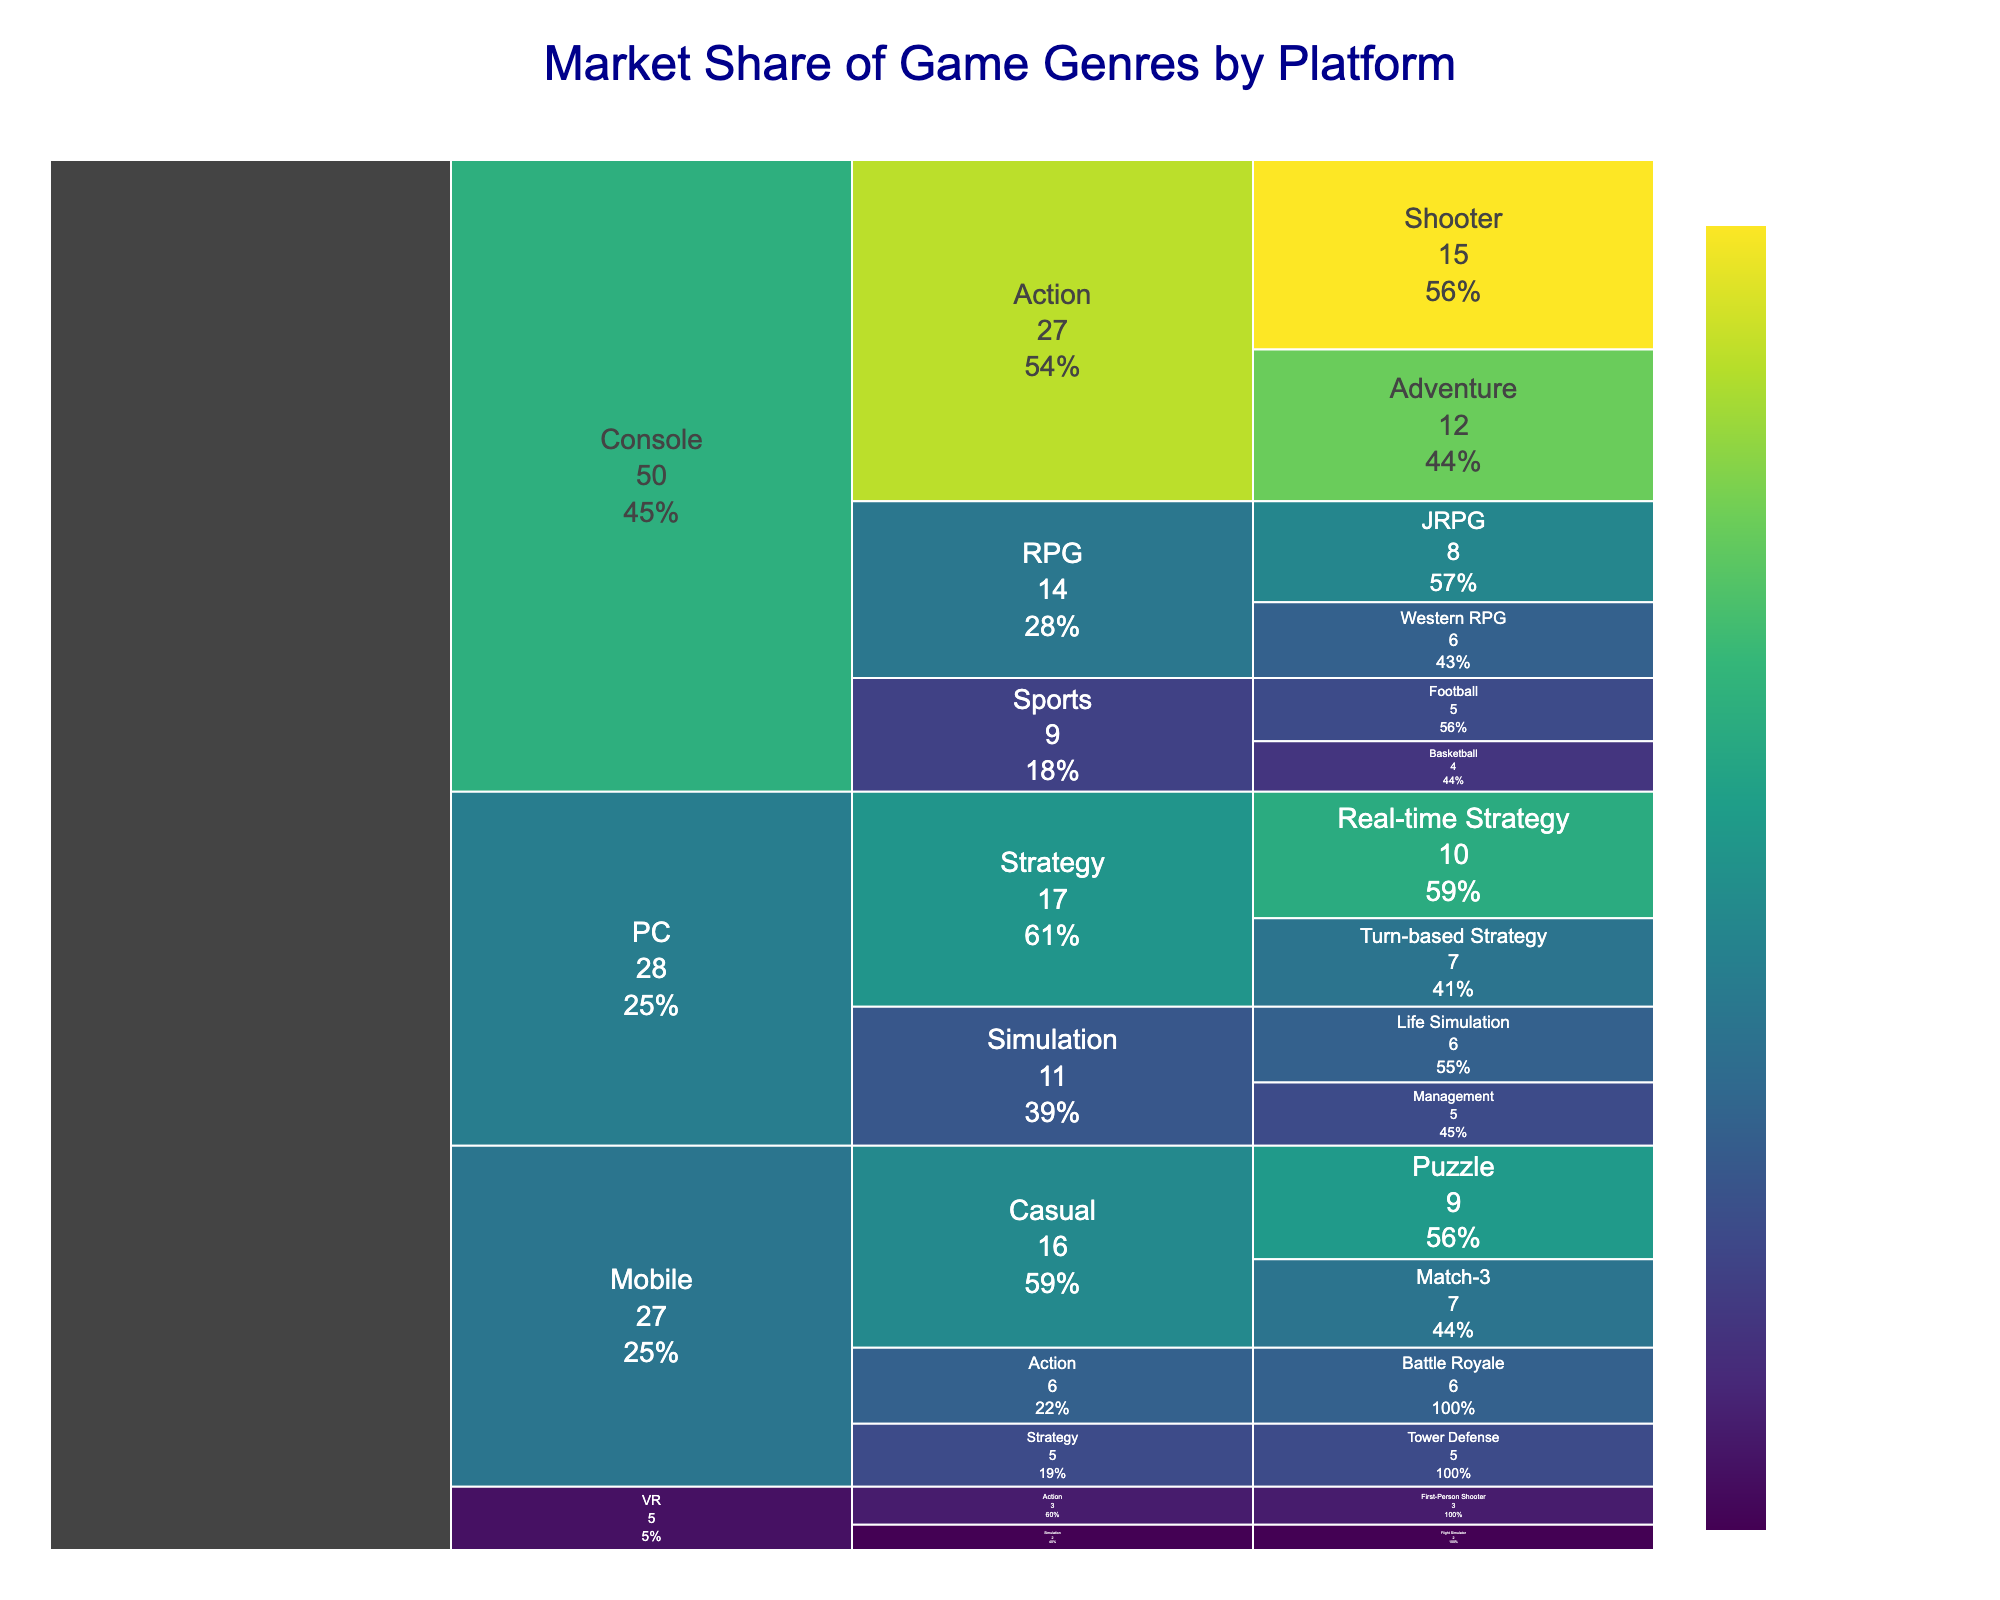What is the title of the chart? The title of the chart is usually displayed at the top and is meant to summarize the main topic of the chart in a concise manner. In this case, it displays information about game genres market share by platform.
Answer: Market Share of Game Genres by Platform Which subgenre under the "Console" platform has the highest market share? To determine this, we need to look under the "Console" section and identify the subgenre with the largest value. The "Shooter" subgenre in the "Action" genre shows the highest share.
Answer: Shooter What is the total market share percentage for the "Strategy" genre across all platforms? We sum the market shares of all subgenres within the "Strategy" genre from the different platforms. Real-time Strategy (10) + Turn-based Strategy (7) + Tower Defense (5).
Answer: 22 Which platform has the smallest presence in the chart based on market share? By examining the values associated with each platform, the VR platform appears to have the smallest presence. It has only two subgenres, and their combined market share is much lower than any other platforms.
Answer: VR Compare the market share of "Casual" games on Mobile with "Action" games on Console. Which one is higher, and by how much? Calculate the total for "Casual" games on Mobile (Puzzle 9 + Match-3 7) and compare it to "Action" games on Console (Shooter 15 + Adventure 12). "Action" on Console has 27, and "Casual" on Mobile has 16, making the difference 27 - 16.
Answer: Action games by 11 Which genre under the "PC" platform has a higher market share, "Simulation" or "Strategy"? Look at the market share for the subgenres under each genre on the PC platform. "Simulation" (Life Simulation 6 + Management 5) sums to 11, while "Strategy" (Real-time Strategy 10 + Turn-based Strategy 7) sums to 17.
Answer: Strategy What percentage of the market share does "JRPG" under the "RPG" genre on Console hold? This value is directly given in the chart under the "JRPG" subgenre in the "RPG" genre on the Console platform.
Answer: 8% Identify all the subgenres that have a market share of exactly 5% and list their platforms. By reviewing each subgenre and its corresponding market share, we can identify those with a value of 5. These include "Football" (Console), "Management" (PC), and "Tower Defense" (Mobile).
Answer: Football (Console), Management (PC), Tower Defense (Mobile) What is the combined market share for all "Action" subgenres across all platforms? Summing the shares of all "Action" subgenres across platforms. Shooter (15) + Adventure (12) + Battle Royale (6) + First-Person Shooter (3).
Answer: 36 